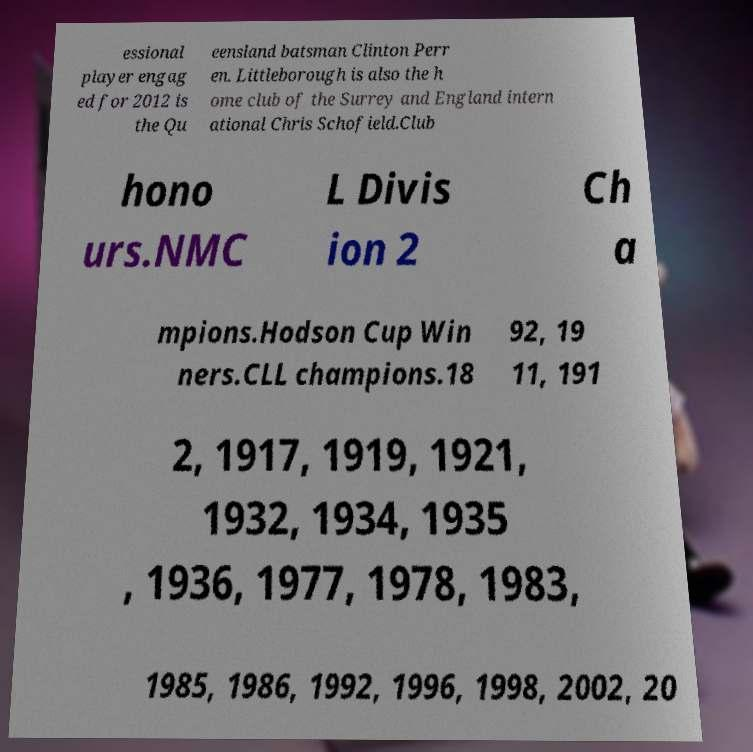What messages or text are displayed in this image? I need them in a readable, typed format. essional player engag ed for 2012 is the Qu eensland batsman Clinton Perr en. Littleborough is also the h ome club of the Surrey and England intern ational Chris Schofield.Club hono urs.NMC L Divis ion 2 Ch a mpions.Hodson Cup Win ners.CLL champions.18 92, 19 11, 191 2, 1917, 1919, 1921, 1932, 1934, 1935 , 1936, 1977, 1978, 1983, 1985, 1986, 1992, 1996, 1998, 2002, 20 